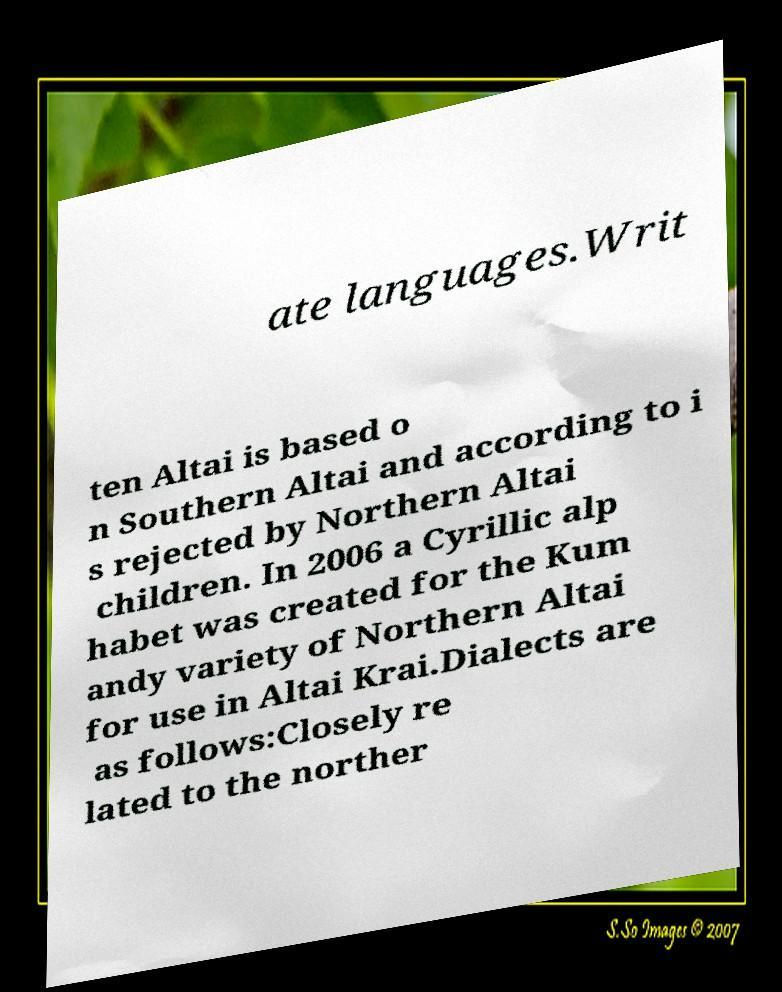Can you read and provide the text displayed in the image?This photo seems to have some interesting text. Can you extract and type it out for me? ate languages.Writ ten Altai is based o n Southern Altai and according to i s rejected by Northern Altai children. In 2006 a Cyrillic alp habet was created for the Kum andy variety of Northern Altai for use in Altai Krai.Dialects are as follows:Closely re lated to the norther 